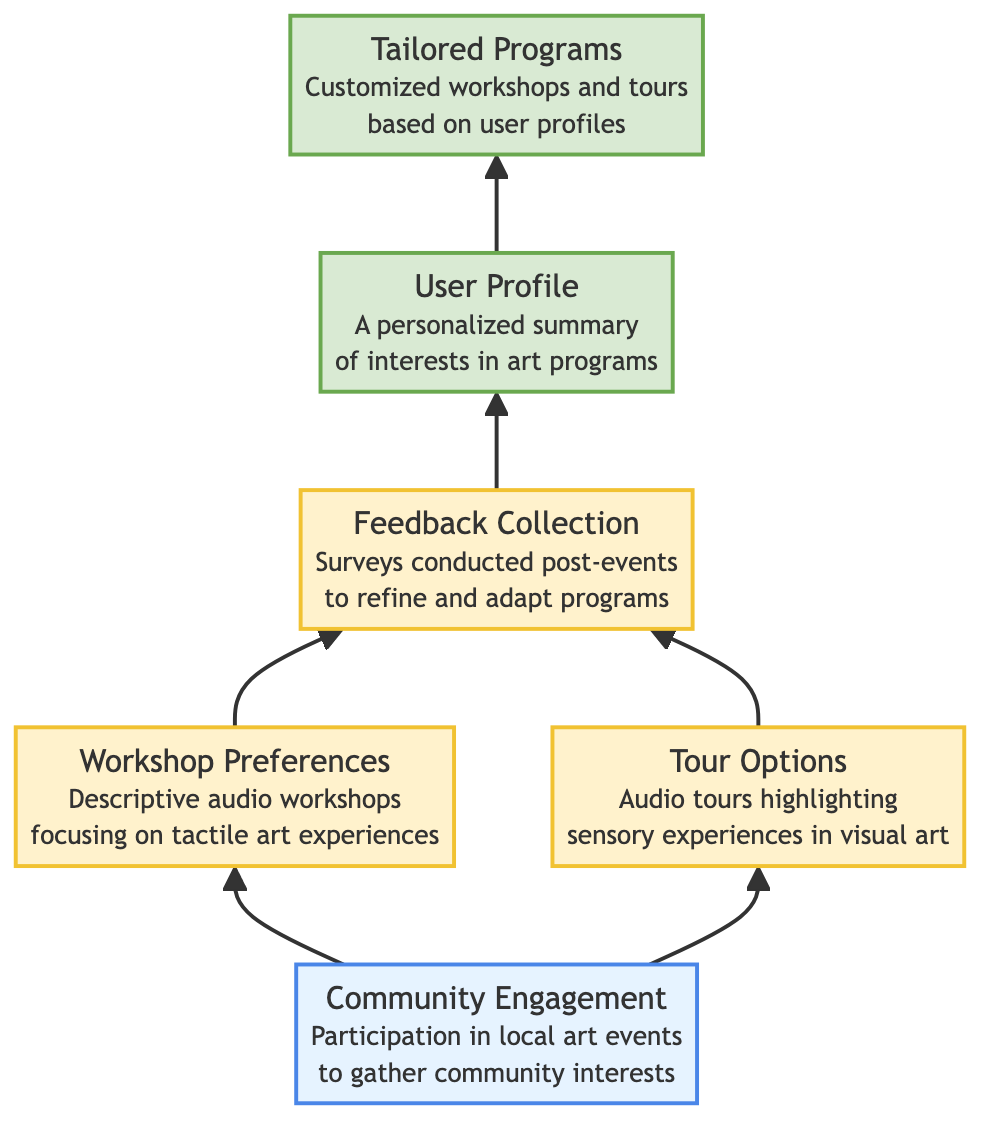What is the input node in the diagram? The diagram's input node is "Community Engagement", which signifies the starting point focusing on gathering community interests through participation in local art events.
Answer: Community Engagement How many output nodes are present in the diagram? The diagram includes two output nodes: "User Profile" and "Tailored Programs". Therefore, by counting these nodes, we find that there are two outputs.
Answer: 2 What process follows "Community Engagement"? After "Community Engagement", the diagram shows two parallel processes: "Workshop Preferences" and "Tour Options", indicating that both areas develop concurrently from the input.
Answer: Workshop Preferences and Tour Options What is the relationship between "User Profile" and "Tailored Programs"? The diagram illustrates that "User Profile" directly leads to "Tailored Programs", indicating that the personalized summary of interests informs the customization of workshops and tours based on user preferences.
Answer: User Profile leads to Tailored Programs What type of workshops are highlighted in the diagram? The diagram specifies the workshops as "Descriptive audio workshops focusing on tactile art experiences", emphasizing the nature and approach of the programmed workshops.
Answer: Descriptive audio workshops focusing on tactile art experiences What is the output of the "Feedback Collection" process? The output of the "Feedback Collection" process is "User Profile". This indicates that after collecting feedback, the next step involves creating a personalized summary of the user's interests in art programs.
Answer: User Profile Explain how "Workshop Preferences" and "Tour Options" are integrated into the overall process. "Workshop Preferences" and "Tour Options" are both processes that follow from the input "Community Engagement". They represent separate pathways of engagement opportunities, but they converge into "Feedback Collection", emphasizing that both aspects are crucial in capturing user input for further refinement.
Answer: They converge into Feedback Collection 